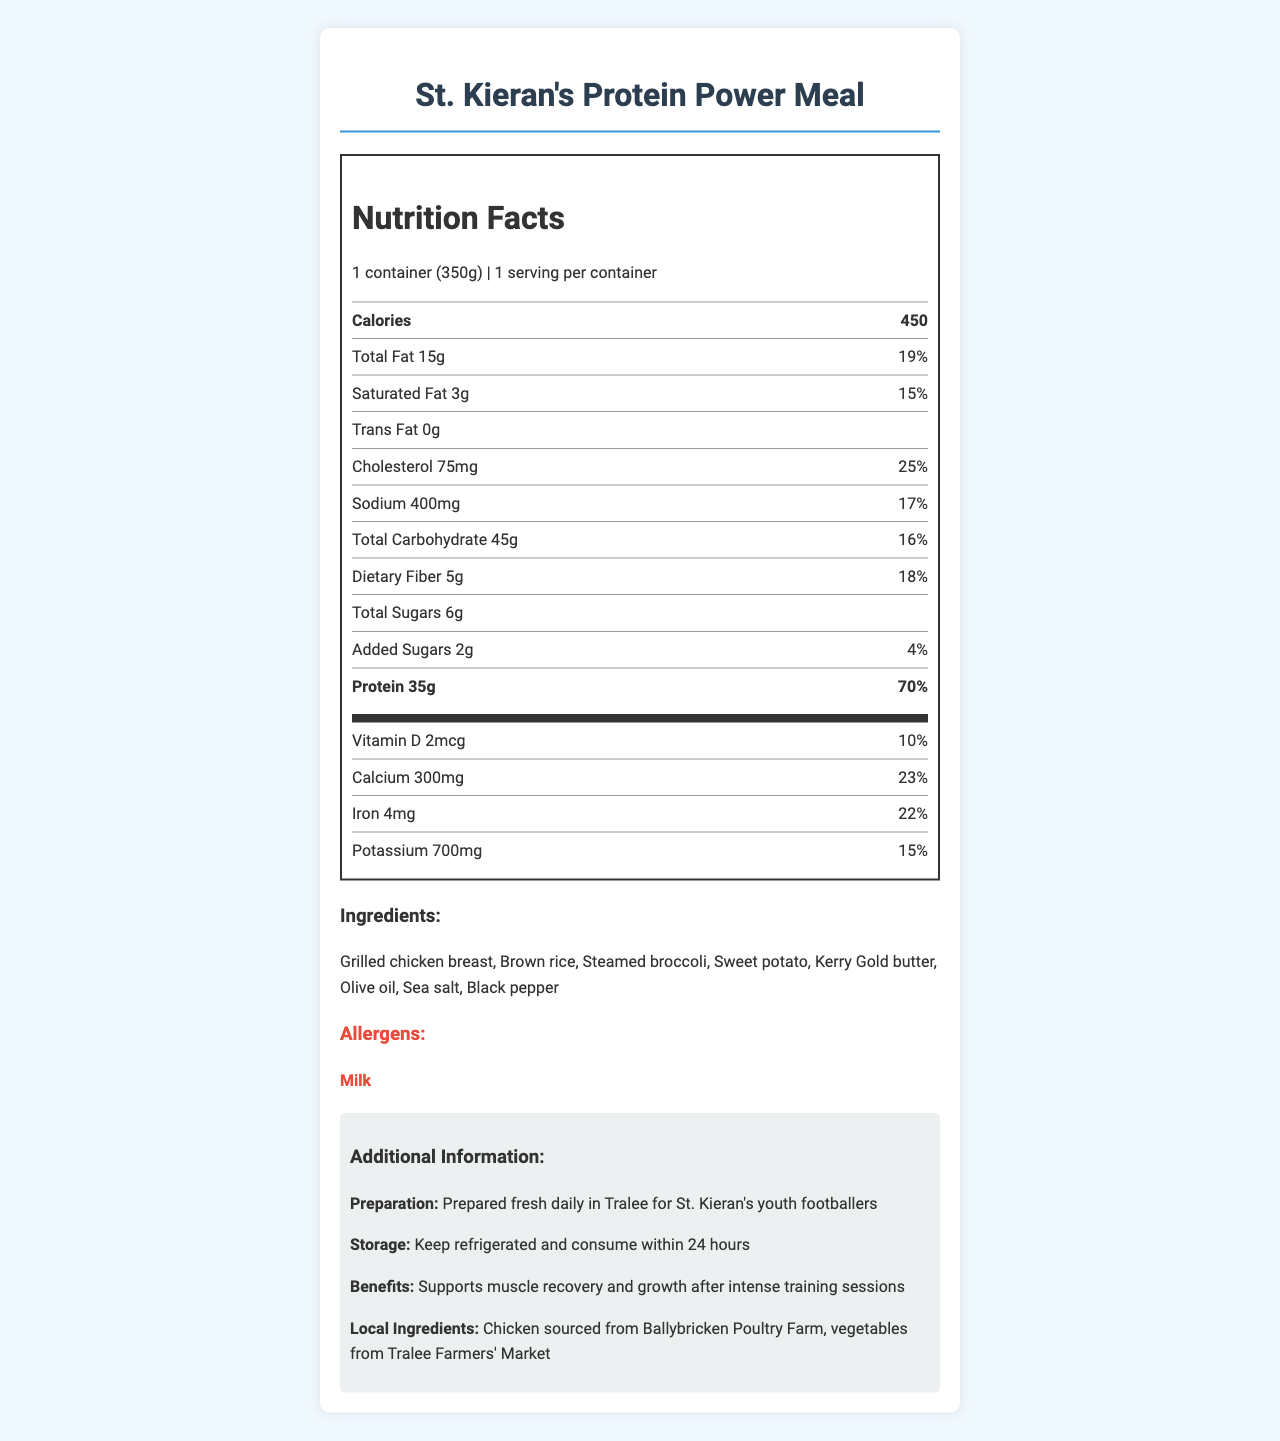what is the serving size of St. Kieran's Protein Power Meal? The serving size is given in the document as "1 container (350g)".
Answer: 1 container (350g) how many calories does one serving of the Protein Power Meal have? The document states that each serving contains 450 calories.
Answer: 450 how much protein is in one serving of the meal? The document indicates that there are 35 grams of protein per serving.
Answer: 35g what percentage of the daily value of calcium does this meal provide? According to the document, the meal provides 23% of the daily value of calcium.
Answer: 23% what is the total carbohydrate content in the meal? The document lists the total carbohydrate content as 45 grams.
Answer: 45g which ingredient is listed as an allergen? The document highlights "Milk" as an allergen in the meal.
Answer: Milk does the meal contain any trans fat? The document indicates that the trans fat content is "0g," so it does not contain any trans fat.
Answer: No what is the main benefit of this meal according to the document? The document states that the main benefit of the meal is to "support muscle recovery and growth after intense training sessions".
Answer: Supports muscle recovery and growth after intense training sessions. where is the chicken for the meal sourced from? A. Tralee Farmers' Market B. Ballybricken Poultry Farm C. County Kerry D. St. Kieran's The document specifies that the chicken is sourced from Ballybricken Poultry Farm.
Answer: B. Ballybricken Poultry Farm how should the meal be stored? A. Keep frozen B. Refrigerate after opening C. Keep refrigerated and consume within 24 hours D. Store in a cool, dry place The document instructs to "Keep refrigerated and consume within 24 hours" for storage.
Answer: C. Keep refrigerated and consume within 24 hours does the meal have more dietary fiber or total sugars? The document lists 5g of dietary fiber and 6g of total sugars.
Answer: Dietary fiber how much vitamin D does this meal provide in micrograms? The document states that the meal provides 2 micrograms of vitamin D.
Answer: 2mcg what are the main ingredients in St. Kieran's Protein Power Meal? These ingredients are listed directly under the "Ingredients" section in the document.
Answer: Grilled chicken breast, brown rice, steamed broccoli, sweet potato, Kerry Gold butter, olive oil, sea salt, black pepper name one of the additional sources of the meal's ingredients. The document mentions that vegetables are sourced from Tralee Farmers' Market.
Answer: Tralee Farmers' Market does the meal contain more cholesterol than sodium? The meal contains 75mg of cholesterol and 400mg of sodium, so it has more sodium.
Answer: No summarize the main information presented in the document. The document covers the nutritional content, ingredients, allergens, preparation and storage instructions, and the benefits of consuming the meal.
Answer: The document provides detailed nutritional information about St. Kieran's Protein Power Meal, which includes a serving size of 1 container (350g) with 450 calories. It outlines the amounts and daily values for fat, cholesterol, sodium, carbohydrates, dietary fiber, sugars, protein, and essential vitamins and minerals. The meal is designed to support muscle recovery and growth for young athletes. The main ingredients and allergens are listed, along with storage instructions and sourcing information from local suppliers. can this meal be consumed by someone with a nut allergy? The document mentions milk as an allergen but does not provide any information about nuts or potential cross-contamination.
Answer: Not enough information 